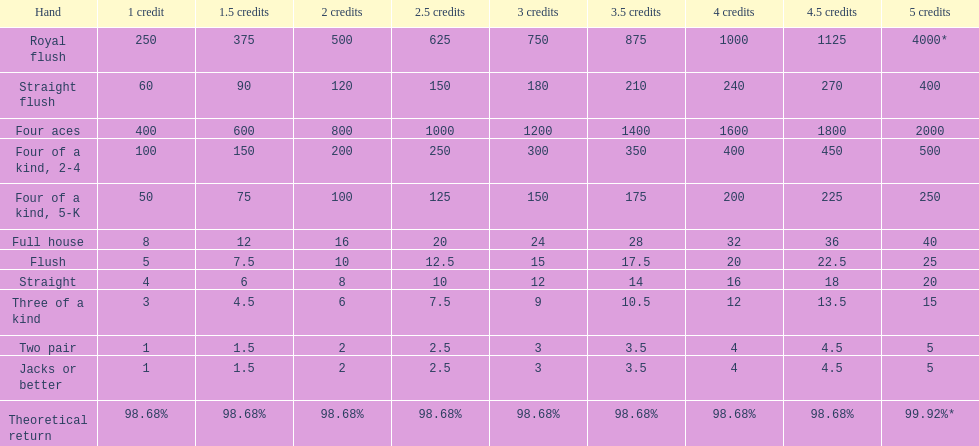At most, what could a person earn for having a full house? 40. 